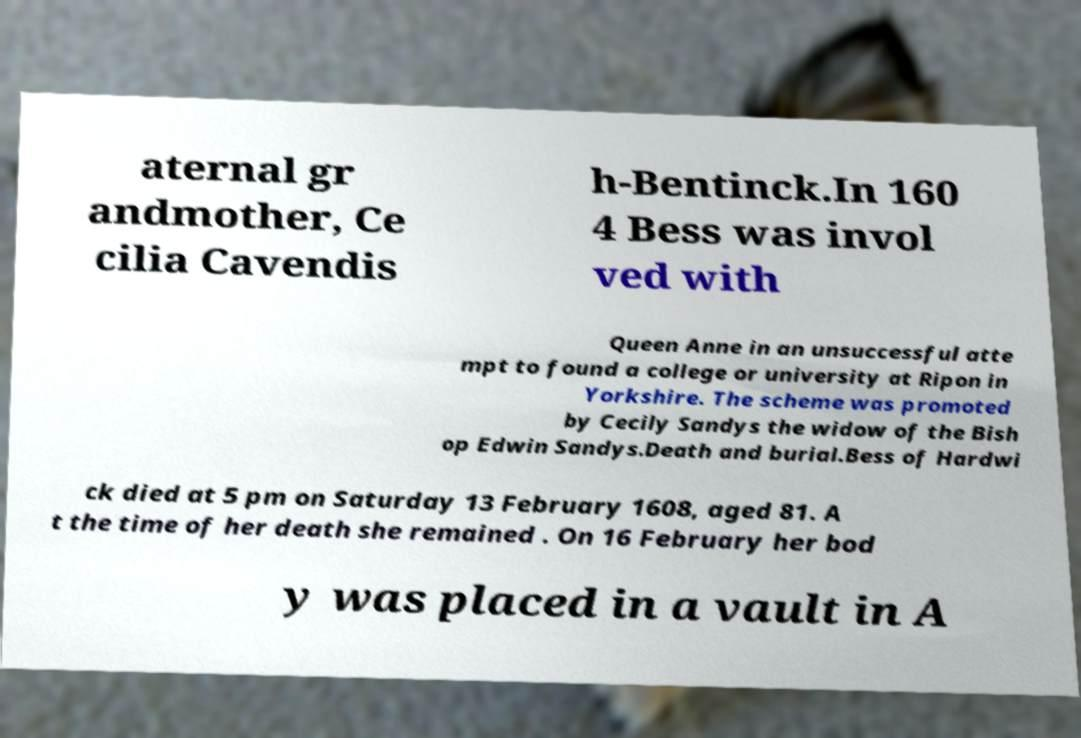Could you extract and type out the text from this image? aternal gr andmother, Ce cilia Cavendis h-Bentinck.In 160 4 Bess was invol ved with Queen Anne in an unsuccessful atte mpt to found a college or university at Ripon in Yorkshire. The scheme was promoted by Cecily Sandys the widow of the Bish op Edwin Sandys.Death and burial.Bess of Hardwi ck died at 5 pm on Saturday 13 February 1608, aged 81. A t the time of her death she remained . On 16 February her bod y was placed in a vault in A 